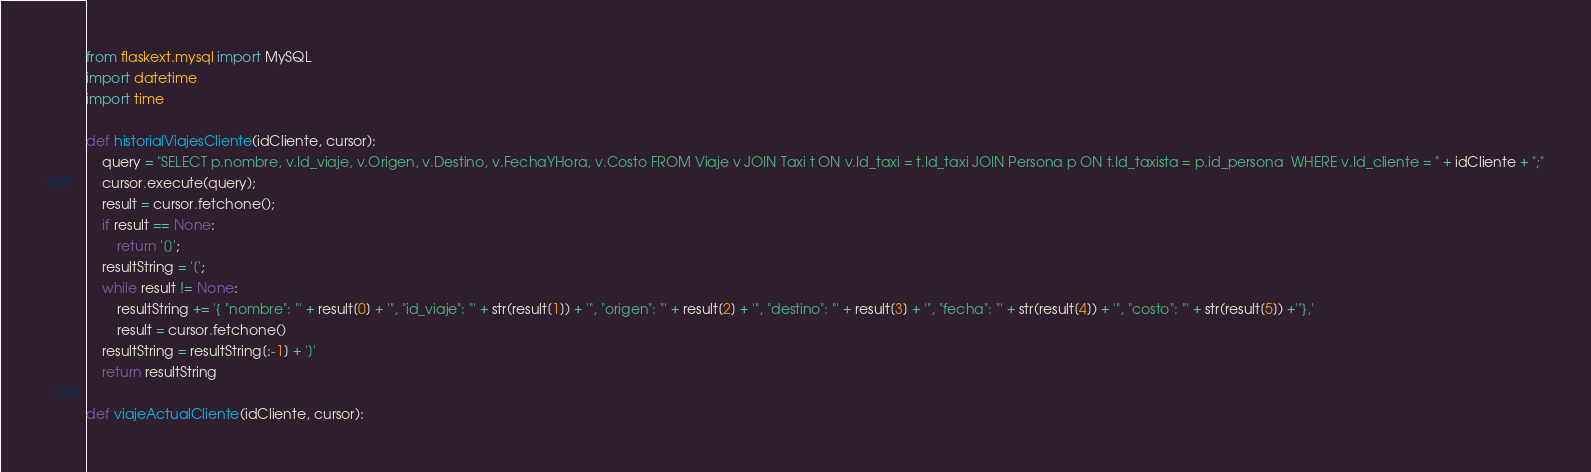<code> <loc_0><loc_0><loc_500><loc_500><_Python_>from flaskext.mysql import MySQL
import datetime
import time

def historialViajesCliente(idCliente, cursor):
	query = "SELECT p.nombre, v.Id_viaje, v.Origen, v.Destino, v.FechaYHora, v.Costo FROM Viaje v JOIN Taxi t ON v.Id_taxi = t.Id_taxi JOIN Persona p ON t.Id_taxista = p.id_persona  WHERE v.Id_cliente = " + idCliente + ";"
	cursor.execute(query);
	result = cursor.fetchone();
	if result == None:
		return '[]';
	resultString = '[';
	while result != None:
		resultString += '{ "nombre": "' + result[0] + '", "id_viaje": "' + str(result[1]) + '", "origen": "' + result[2] + '", "destino": "' + result[3] + '", "fecha": "' + str(result[4]) + '", "costo": "' + str(result[5]) +'"},'
		result = cursor.fetchone()
	resultString = resultString[:-1] + ']'
	return resultString

def viajeActualCliente(idCliente, cursor):</code> 